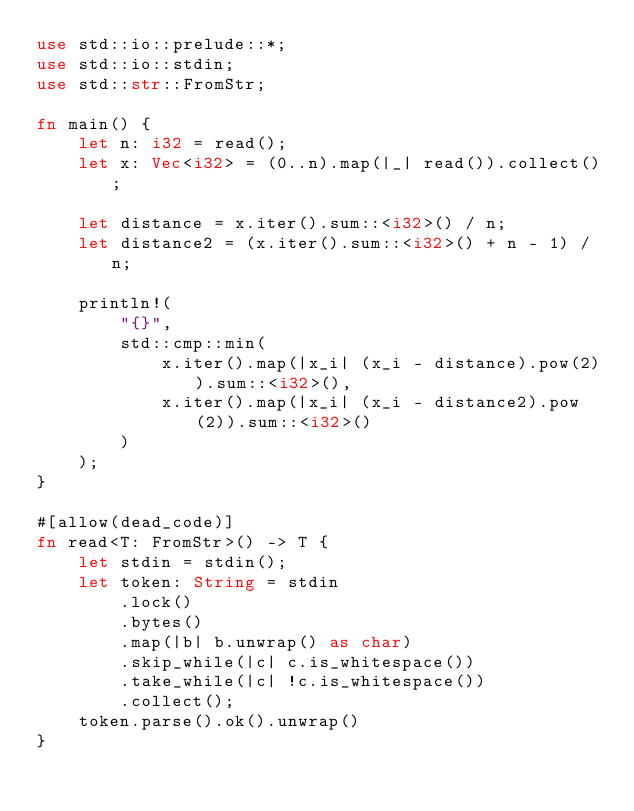Convert code to text. <code><loc_0><loc_0><loc_500><loc_500><_Rust_>use std::io::prelude::*;
use std::io::stdin;
use std::str::FromStr;

fn main() {
    let n: i32 = read();
    let x: Vec<i32> = (0..n).map(|_| read()).collect();

    let distance = x.iter().sum::<i32>() / n;
    let distance2 = (x.iter().sum::<i32>() + n - 1) / n;

    println!(
        "{}",
        std::cmp::min(
            x.iter().map(|x_i| (x_i - distance).pow(2)).sum::<i32>(),
            x.iter().map(|x_i| (x_i - distance2).pow(2)).sum::<i32>()
        )
    );
}

#[allow(dead_code)]
fn read<T: FromStr>() -> T {
    let stdin = stdin();
    let token: String = stdin
        .lock()
        .bytes()
        .map(|b| b.unwrap() as char)
        .skip_while(|c| c.is_whitespace())
        .take_while(|c| !c.is_whitespace())
        .collect();
    token.parse().ok().unwrap()
}
</code> 